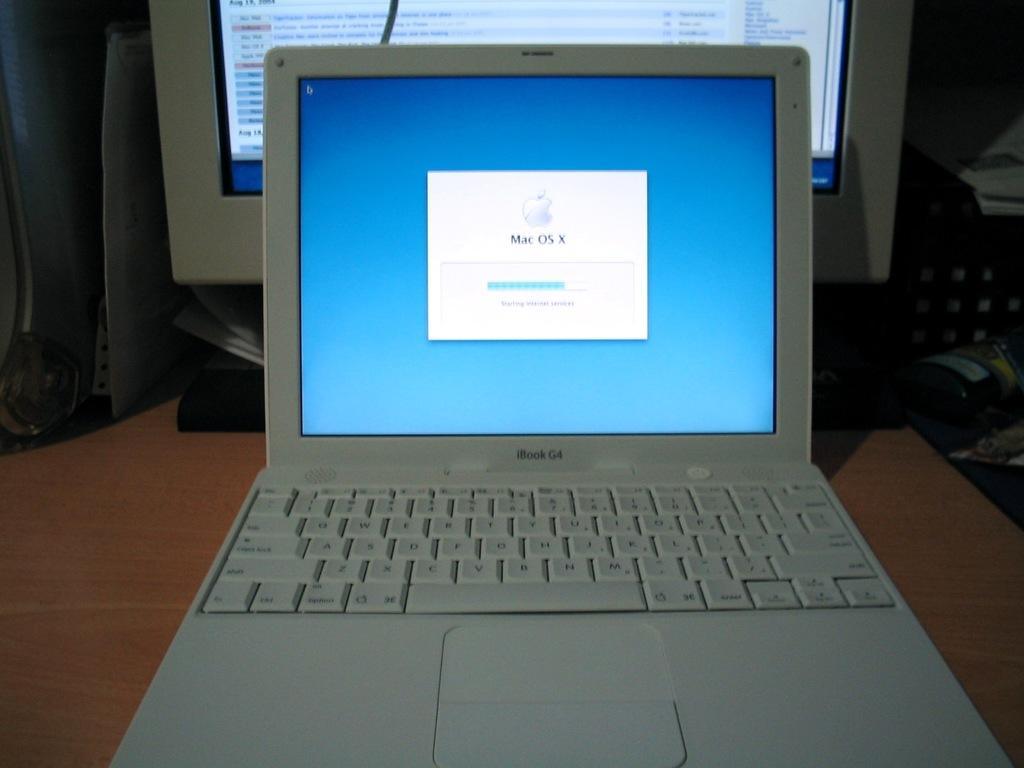<image>
Write a terse but informative summary of the picture. An iBook G4 laptop is open to show a blue screen and the Mac OS X operating system logo. 